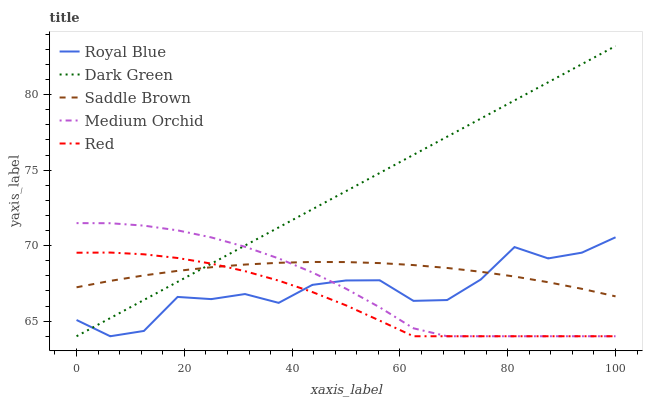Does Red have the minimum area under the curve?
Answer yes or no. Yes. Does Dark Green have the maximum area under the curve?
Answer yes or no. Yes. Does Medium Orchid have the minimum area under the curve?
Answer yes or no. No. Does Medium Orchid have the maximum area under the curve?
Answer yes or no. No. Is Dark Green the smoothest?
Answer yes or no. Yes. Is Royal Blue the roughest?
Answer yes or no. Yes. Is Medium Orchid the smoothest?
Answer yes or no. No. Is Medium Orchid the roughest?
Answer yes or no. No. Does Royal Blue have the lowest value?
Answer yes or no. Yes. Does Saddle Brown have the lowest value?
Answer yes or no. No. Does Dark Green have the highest value?
Answer yes or no. Yes. Does Medium Orchid have the highest value?
Answer yes or no. No. Does Royal Blue intersect Medium Orchid?
Answer yes or no. Yes. Is Royal Blue less than Medium Orchid?
Answer yes or no. No. Is Royal Blue greater than Medium Orchid?
Answer yes or no. No. 